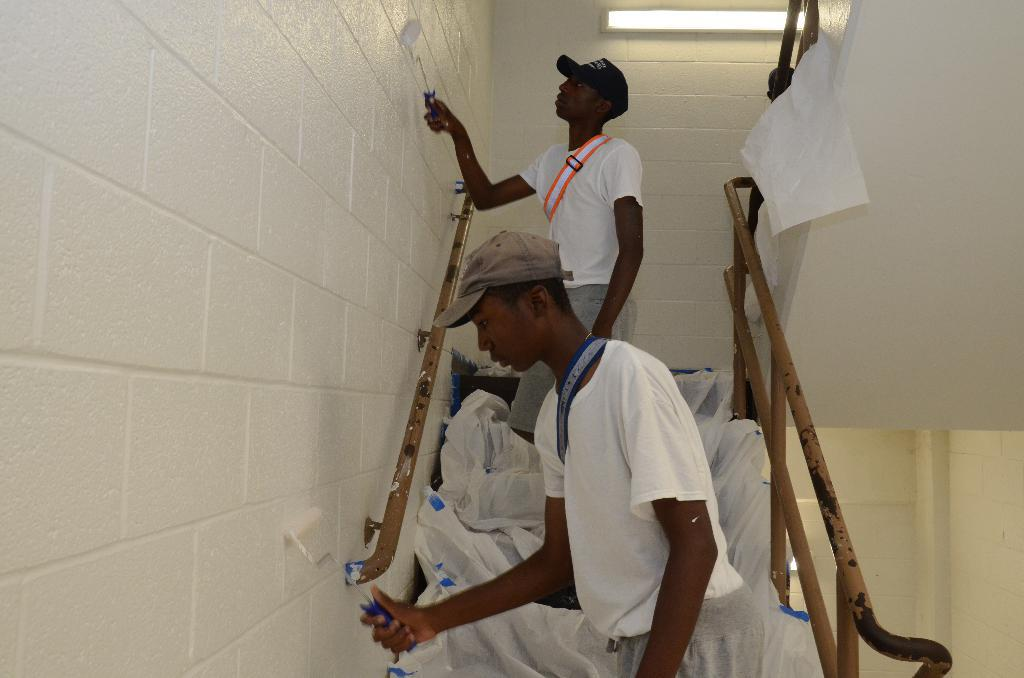How many people are in the image? There are two men in the image. What are the men doing in the image? The men are standing on steps. What are the men holding in their hands? The men are holding objects in their hands. What architectural feature can be seen in the image? There are stairs and a wall in the image. What other objects are present in the image? There are other objects present in the image. Can you see a bear walking up the stairs in the image? No, there is no bear present in the image, and the men are standing, not walking. 